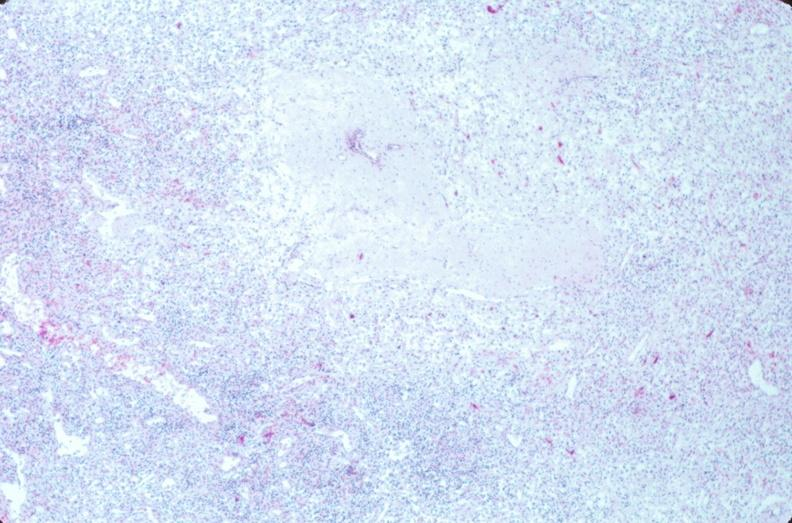what does this image show?
Answer the question using a single word or phrase. Lymph nodes 